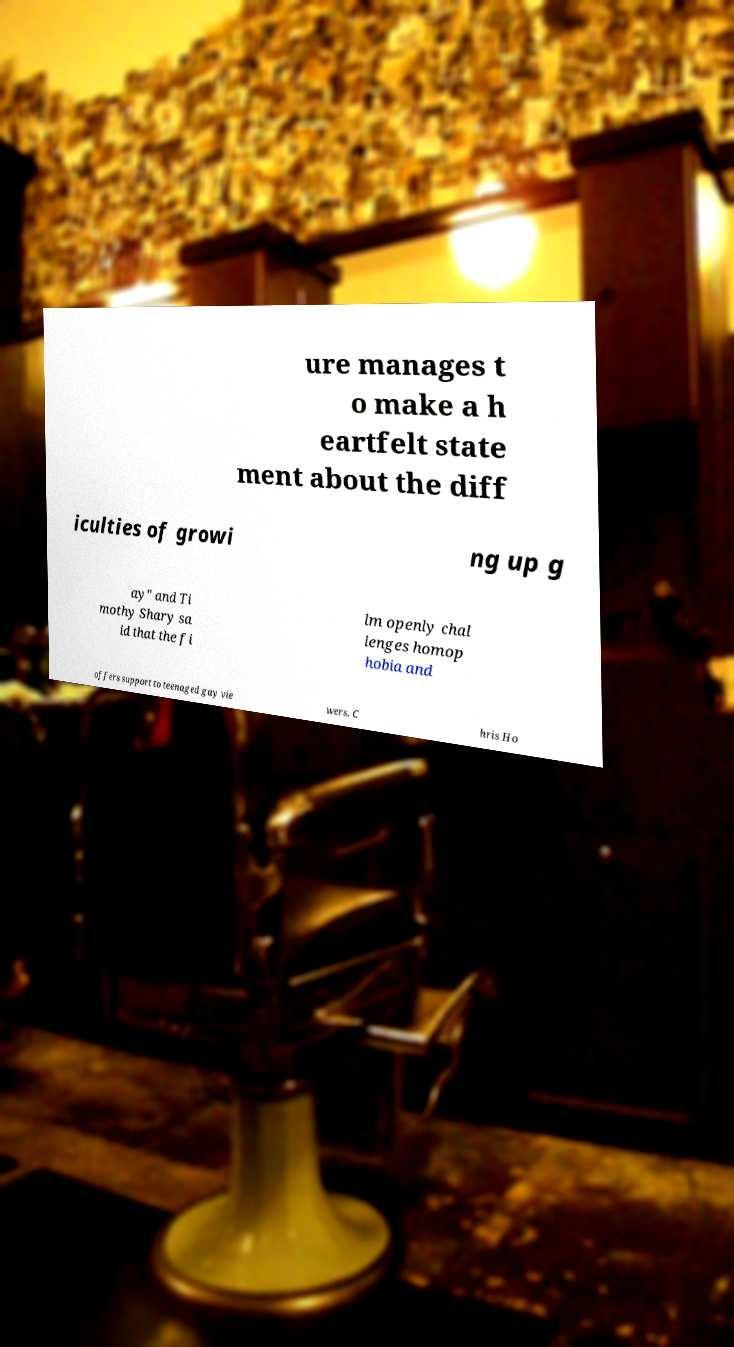Could you extract and type out the text from this image? ure manages t o make a h eartfelt state ment about the diff iculties of growi ng up g ay" and Ti mothy Shary sa id that the fi lm openly chal lenges homop hobia and offers support to teenaged gay vie wers. C hris Ho 